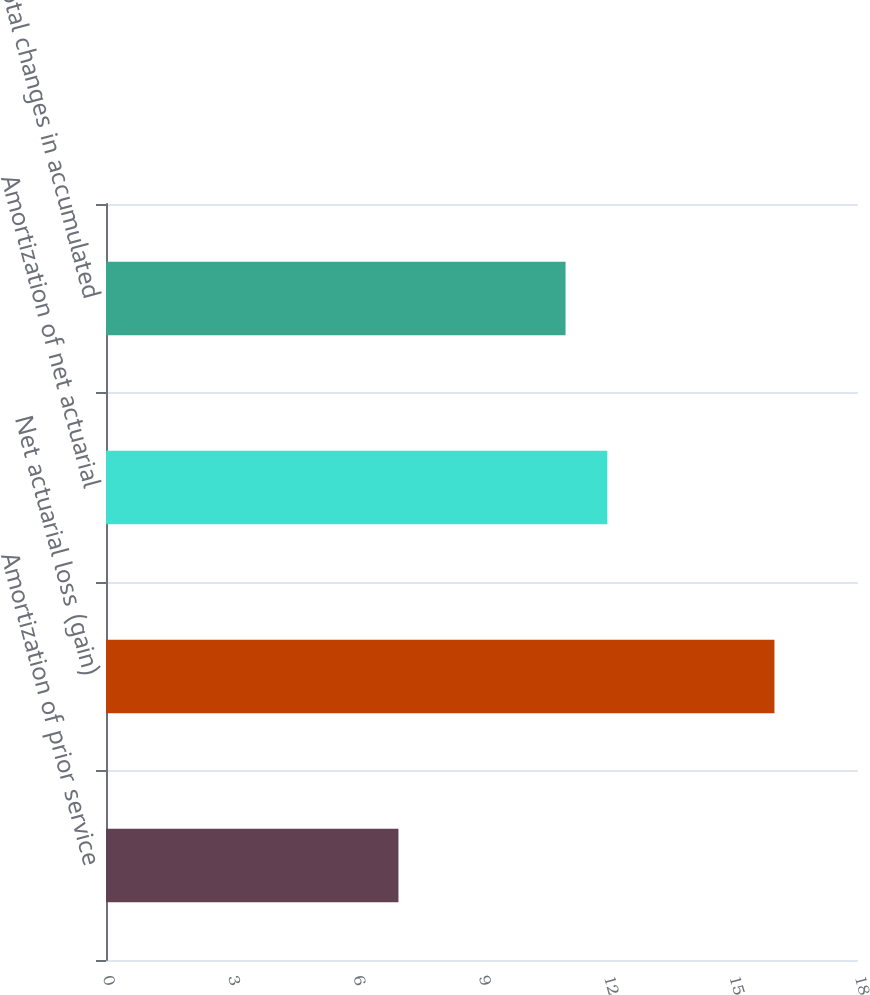Convert chart. <chart><loc_0><loc_0><loc_500><loc_500><bar_chart><fcel>Amortization of prior service<fcel>Net actuarial loss (gain)<fcel>Amortization of net actuarial<fcel>Total changes in accumulated<nl><fcel>7<fcel>16<fcel>12<fcel>11<nl></chart> 